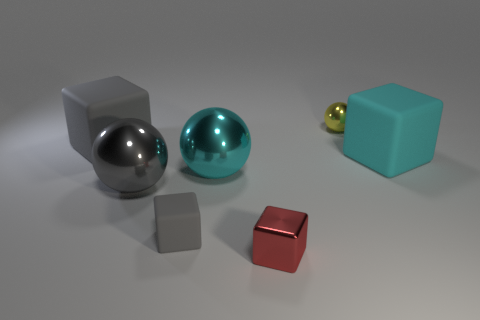Can you describe the textures of the objects in the image? Certainly! In the image, the objects exhibit various textures: the spheres seem to have a smooth, reflective surface, while the cubes appear to have a more matte, slightly rough texture. 